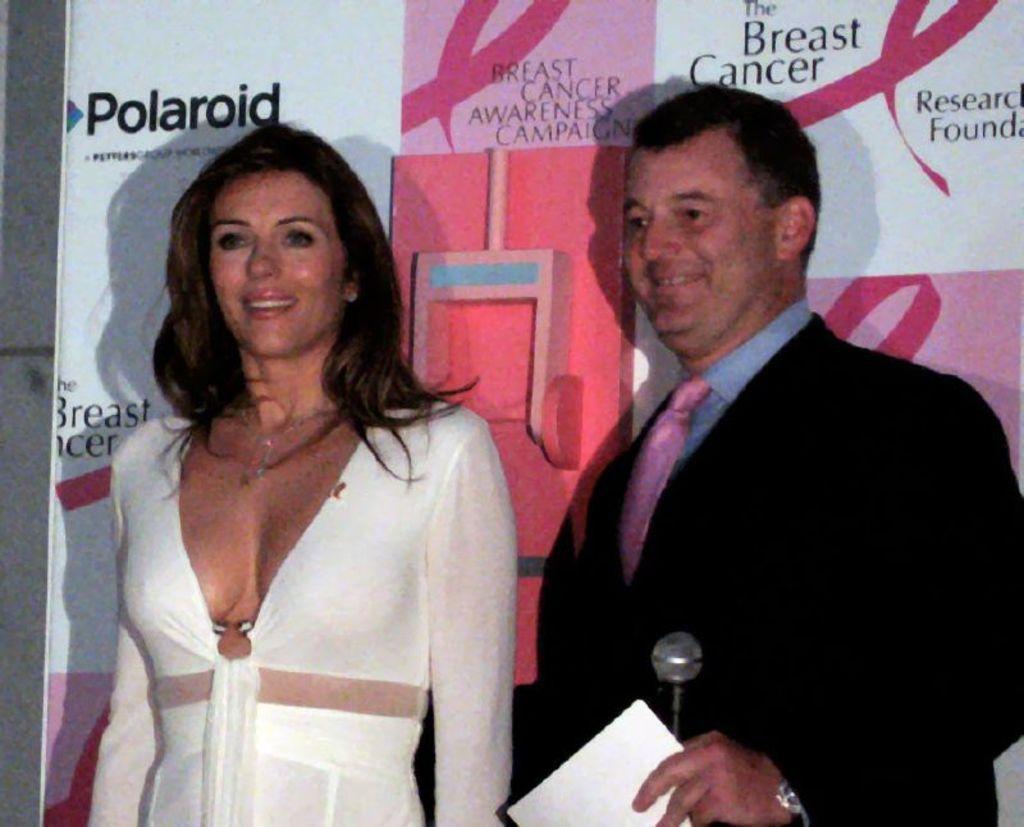In one or two sentences, can you explain what this image depicts? In the picture I can see a man on the right side and there is a smile on his face. He is wearing a suit and a tie and he is holding a microphone and papers in his hand. There is a woman on the left side and she is smiling as well. In the background, I can see the hoarding. 